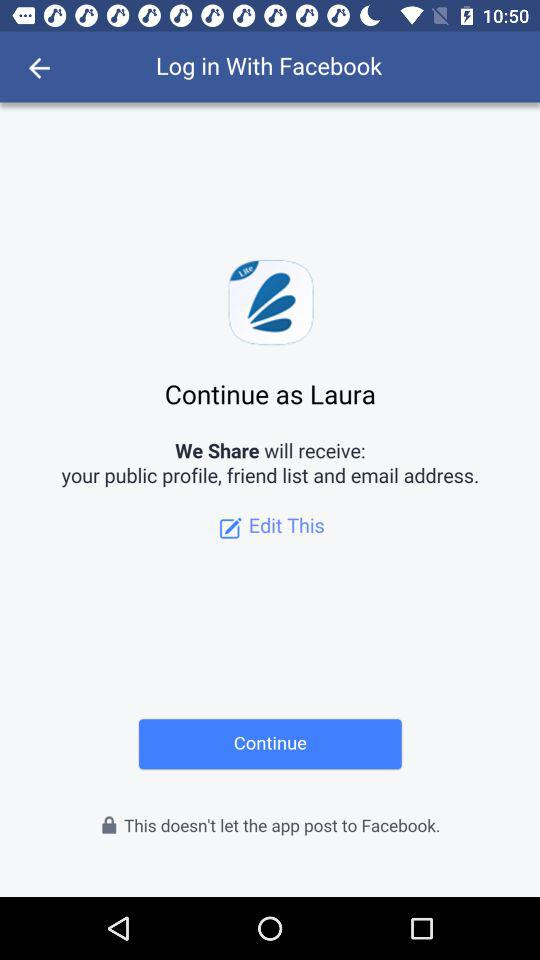What application will receive the public profile, friend list and email address? The application that will receive the public profile, friend list and email address is "We Share". 